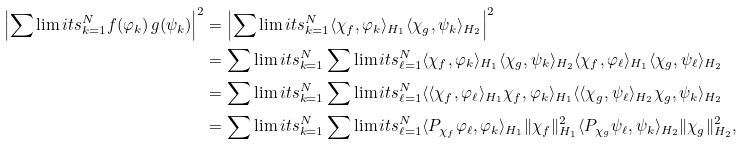<formula> <loc_0><loc_0><loc_500><loc_500>\left | \sum \lim i t s _ { k = 1 } ^ { N } f ( \varphi _ { k } ) \, g ( \psi _ { k } ) \right | ^ { 2 } & = \left | \sum \lim i t s _ { k = 1 } ^ { N } \langle \chi _ { f } , \varphi _ { k } \rangle _ { H _ { 1 } } \langle \chi _ { g } , \psi _ { k } \rangle _ { H _ { 2 } } \right | ^ { 2 } \\ & = \sum \lim i t s _ { k = 1 } ^ { N } \sum \lim i t s _ { \ell = 1 } ^ { N } \langle \chi _ { f } , \varphi _ { k } \rangle _ { H _ { 1 } } \langle \chi _ { g } , \psi _ { k } \rangle _ { H _ { 2 } } \langle \chi _ { f } , \varphi _ { \ell } \rangle _ { H _ { 1 } } \langle \chi _ { g } , \psi _ { \ell } \rangle _ { H _ { 2 } } \\ & = \sum \lim i t s _ { k = 1 } ^ { N } \sum \lim i t s _ { \ell = 1 } ^ { N } \langle \langle \chi _ { f } , \varphi _ { \ell } \rangle _ { H _ { 1 } } \chi _ { f } , \varphi _ { k } \rangle _ { H _ { 1 } } \langle \langle \chi _ { g } , \psi _ { \ell } \rangle _ { H _ { 2 } } \chi _ { g } , \psi _ { k } \rangle _ { H _ { 2 } } \\ & = \sum \lim i t s _ { k = 1 } ^ { N } \sum \lim i t s _ { \ell = 1 } ^ { N } \langle P _ { \chi _ { f } } \varphi _ { \ell } , \varphi _ { k } \rangle _ { H _ { 1 } } \| \chi _ { f } \| _ { H _ { 1 } } ^ { 2 } \langle P _ { \chi _ { g } } \psi _ { \ell } , \psi _ { k } \rangle _ { H _ { 2 } } \| \chi _ { g } \| _ { H _ { 2 } } ^ { 2 } ,</formula> 